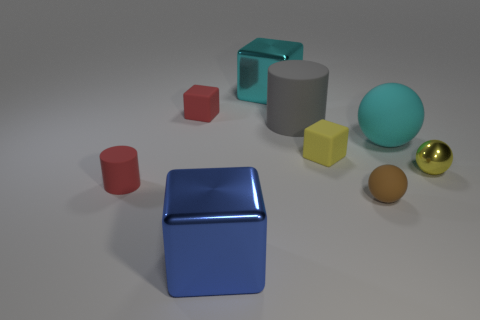How many small objects are green spheres or red objects?
Offer a terse response. 2. There is another tiny rubber thing that is the same shape as the yellow rubber object; what color is it?
Offer a terse response. Red. Is the size of the yellow matte object the same as the gray rubber cylinder?
Provide a short and direct response. No. How many things are cubes or cubes that are behind the blue shiny object?
Make the answer very short. 4. What is the color of the cylinder that is in front of the rubber ball that is behind the tiny brown matte sphere?
Your response must be concise. Red. Does the small rubber block that is in front of the tiny red cube have the same color as the large sphere?
Keep it short and to the point. No. What material is the big cube that is in front of the small shiny sphere?
Keep it short and to the point. Metal. The cyan matte object is what size?
Ensure brevity in your answer.  Large. Does the cylinder right of the small cylinder have the same material as the tiny yellow ball?
Offer a terse response. No. How many small gray matte objects are there?
Ensure brevity in your answer.  0. 